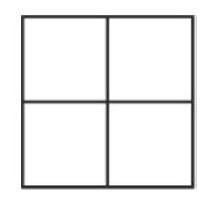If I wanted to maximize the sum of the diagonal from the top-left to the bottom-right, which numbers should I place in those cells? To maximize the diagonal sum from the top-left to the bottom-right, you would place the highest numbers in the diagonal cells. Therefore, you should place the number 4 in the bottom-right cell and the number 3 in the top-left cell, which would give you a sum of 7 for that diagonal. 